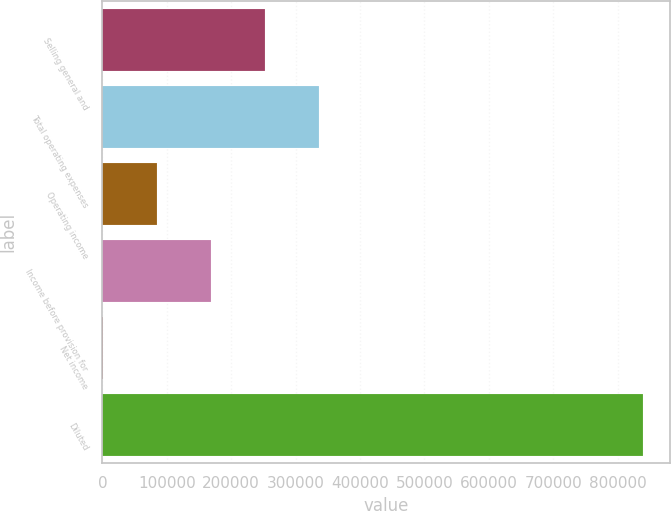<chart> <loc_0><loc_0><loc_500><loc_500><bar_chart><fcel>Selling general and<fcel>Total operating expenses<fcel>Operating income<fcel>Income before provision for<fcel>Net income<fcel>Diluted<nl><fcel>251847<fcel>335698<fcel>84144.2<fcel>167995<fcel>293<fcel>838805<nl></chart> 